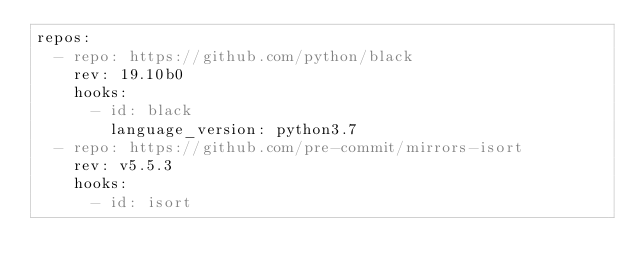Convert code to text. <code><loc_0><loc_0><loc_500><loc_500><_YAML_>repos:
  - repo: https://github.com/python/black
    rev: 19.10b0
    hooks:
      - id: black
        language_version: python3.7
  - repo: https://github.com/pre-commit/mirrors-isort
    rev: v5.5.3
    hooks:
      - id: isort
</code> 